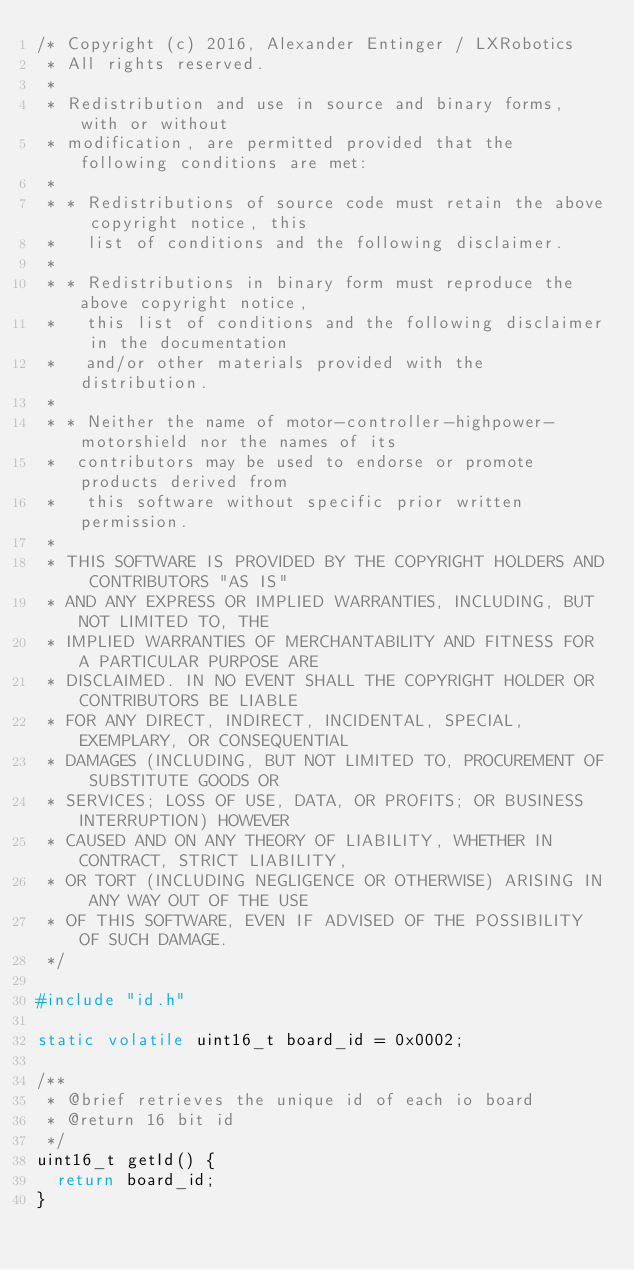Convert code to text. <code><loc_0><loc_0><loc_500><loc_500><_C_>/* Copyright (c) 2016, Alexander Entinger / LXRobotics
 * All rights reserved.
 * 
 * Redistribution and use in source and binary forms, with or without
 * modification, are permitted provided that the following conditions are met:
 * 
 * * Redistributions of source code must retain the above copyright notice, this
 *   list of conditions and the following disclaimer.
 * 
 * * Redistributions in binary form must reproduce the above copyright notice,
 *   this list of conditions and the following disclaimer in the documentation
 *   and/or other materials provided with the distribution.
 * 
 * * Neither the name of motor-controller-highpower-motorshield nor the names of its
 *  contributors may be used to endorse or promote products derived from
 *   this software without specific prior written permission.
 * 
 * THIS SOFTWARE IS PROVIDED BY THE COPYRIGHT HOLDERS AND CONTRIBUTORS "AS IS"
 * AND ANY EXPRESS OR IMPLIED WARRANTIES, INCLUDING, BUT NOT LIMITED TO, THE
 * IMPLIED WARRANTIES OF MERCHANTABILITY AND FITNESS FOR A PARTICULAR PURPOSE ARE
 * DISCLAIMED. IN NO EVENT SHALL THE COPYRIGHT HOLDER OR CONTRIBUTORS BE LIABLE
 * FOR ANY DIRECT, INDIRECT, INCIDENTAL, SPECIAL, EXEMPLARY, OR CONSEQUENTIAL
 * DAMAGES (INCLUDING, BUT NOT LIMITED TO, PROCUREMENT OF SUBSTITUTE GOODS OR
 * SERVICES; LOSS OF USE, DATA, OR PROFITS; OR BUSINESS INTERRUPTION) HOWEVER
 * CAUSED AND ON ANY THEORY OF LIABILITY, WHETHER IN CONTRACT, STRICT LIABILITY,
 * OR TORT (INCLUDING NEGLIGENCE OR OTHERWISE) ARISING IN ANY WAY OUT OF THE USE
 * OF THIS SOFTWARE, EVEN IF ADVISED OF THE POSSIBILITY OF SUCH DAMAGE.
 */

#include "id.h"

static volatile uint16_t board_id = 0x0002;

/**
 * @brief retrieves the unique id of each io board
 * @return 16 bit id
 */
uint16_t getId() {
	return board_id;
}
</code> 